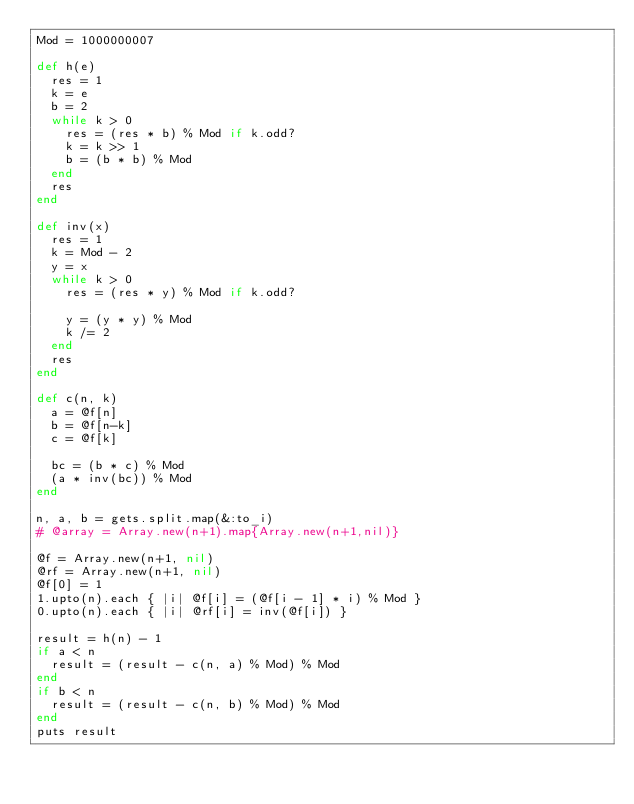<code> <loc_0><loc_0><loc_500><loc_500><_Ruby_>Mod = 1000000007

def h(e)
  res = 1
  k = e
  b = 2
  while k > 0
    res = (res * b) % Mod if k.odd?
    k = k >> 1
    b = (b * b) % Mod
  end
  res
end

def inv(x)
  res = 1
  k = Mod - 2
  y = x
  while k > 0
    res = (res * y) % Mod if k.odd?

    y = (y * y) % Mod
    k /= 2
  end
  res
end

def c(n, k)
  a = @f[n]
  b = @f[n-k]
  c = @f[k]

  bc = (b * c) % Mod
  (a * inv(bc)) % Mod
end

n, a, b = gets.split.map(&:to_i)
# @array = Array.new(n+1).map{Array.new(n+1,nil)}

@f = Array.new(n+1, nil)
@rf = Array.new(n+1, nil)
@f[0] = 1
1.upto(n).each { |i| @f[i] = (@f[i - 1] * i) % Mod }
0.upto(n).each { |i| @rf[i] = inv(@f[i]) }

result = h(n) - 1
if a < n
  result = (result - c(n, a) % Mod) % Mod
end
if b < n
  result = (result - c(n, b) % Mod) % Mod
end
puts result</code> 